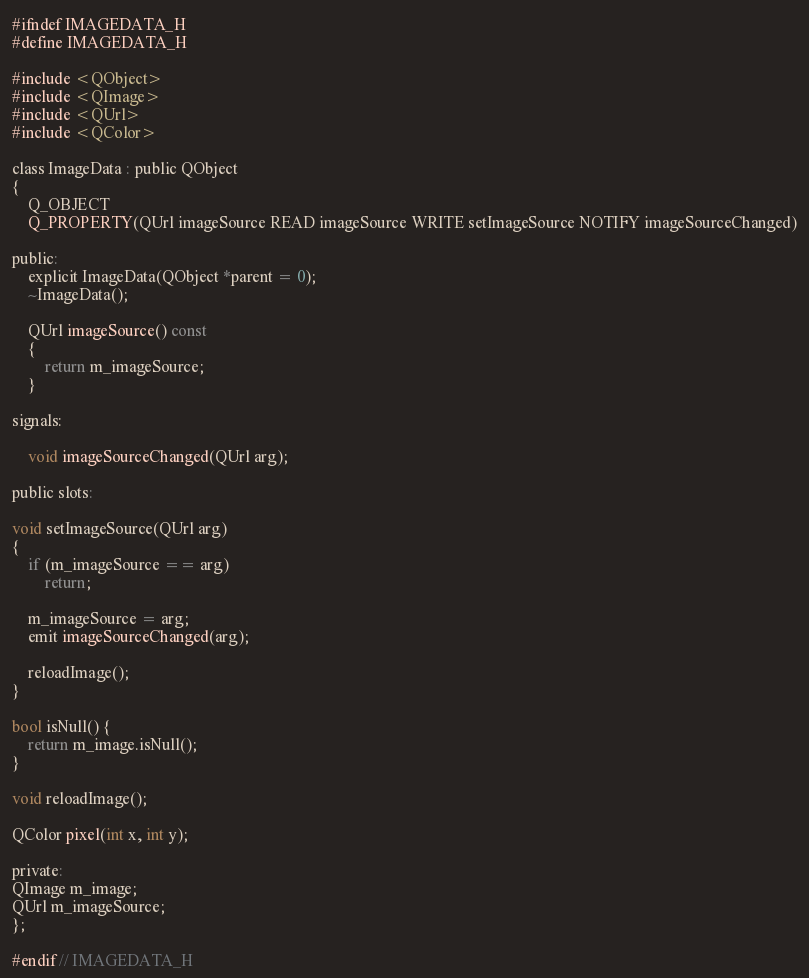Convert code to text. <code><loc_0><loc_0><loc_500><loc_500><_C_>#ifndef IMAGEDATA_H
#define IMAGEDATA_H

#include <QObject>
#include <QImage>
#include <QUrl>
#include <QColor>

class ImageData : public QObject
{
    Q_OBJECT
    Q_PROPERTY(QUrl imageSource READ imageSource WRITE setImageSource NOTIFY imageSourceChanged)

public:
    explicit ImageData(QObject *parent = 0);
    ~ImageData();

    QUrl imageSource() const
    {
        return m_imageSource;
    }

signals:

    void imageSourceChanged(QUrl arg);

public slots:

void setImageSource(QUrl arg)
{
    if (m_imageSource == arg)
        return;

    m_imageSource = arg;
    emit imageSourceChanged(arg);

    reloadImage();
}

bool isNull() {
    return m_image.isNull();
}

void reloadImage();

QColor pixel(int x, int y);

private:
QImage m_image;
QUrl m_imageSource;
};

#endif // IMAGEDATA_H
</code> 